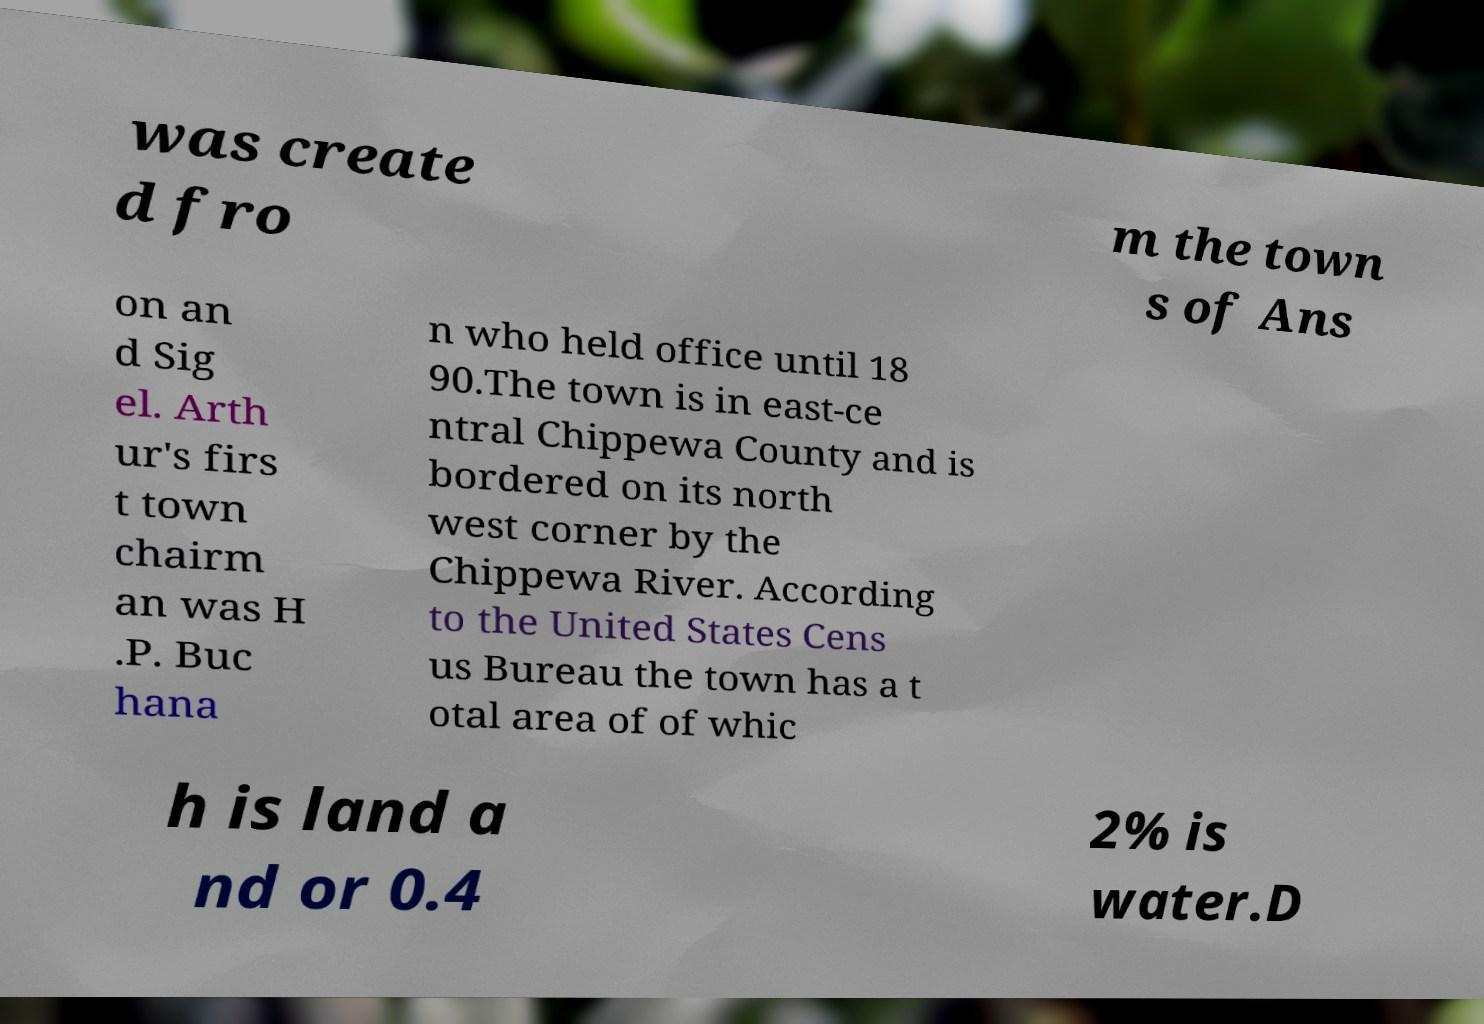For documentation purposes, I need the text within this image transcribed. Could you provide that? was create d fro m the town s of Ans on an d Sig el. Arth ur's firs t town chairm an was H .P. Buc hana n who held office until 18 90.The town is in east-ce ntral Chippewa County and is bordered on its north west corner by the Chippewa River. According to the United States Cens us Bureau the town has a t otal area of of whic h is land a nd or 0.4 2% is water.D 